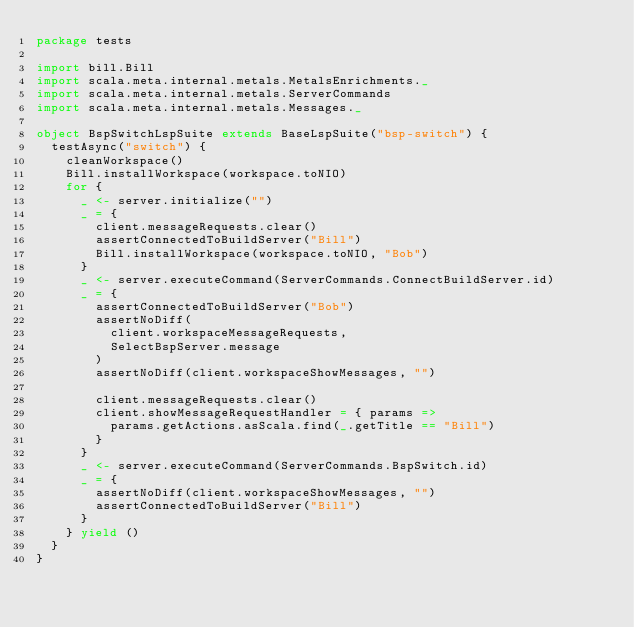<code> <loc_0><loc_0><loc_500><loc_500><_Scala_>package tests

import bill.Bill
import scala.meta.internal.metals.MetalsEnrichments._
import scala.meta.internal.metals.ServerCommands
import scala.meta.internal.metals.Messages._

object BspSwitchLspSuite extends BaseLspSuite("bsp-switch") {
  testAsync("switch") {
    cleanWorkspace()
    Bill.installWorkspace(workspace.toNIO)
    for {
      _ <- server.initialize("")
      _ = {
        client.messageRequests.clear()
        assertConnectedToBuildServer("Bill")
        Bill.installWorkspace(workspace.toNIO, "Bob")
      }
      _ <- server.executeCommand(ServerCommands.ConnectBuildServer.id)
      _ = {
        assertConnectedToBuildServer("Bob")
        assertNoDiff(
          client.workspaceMessageRequests,
          SelectBspServer.message
        )
        assertNoDiff(client.workspaceShowMessages, "")

        client.messageRequests.clear()
        client.showMessageRequestHandler = { params =>
          params.getActions.asScala.find(_.getTitle == "Bill")
        }
      }
      _ <- server.executeCommand(ServerCommands.BspSwitch.id)
      _ = {
        assertNoDiff(client.workspaceShowMessages, "")
        assertConnectedToBuildServer("Bill")
      }
    } yield ()
  }
}
</code> 